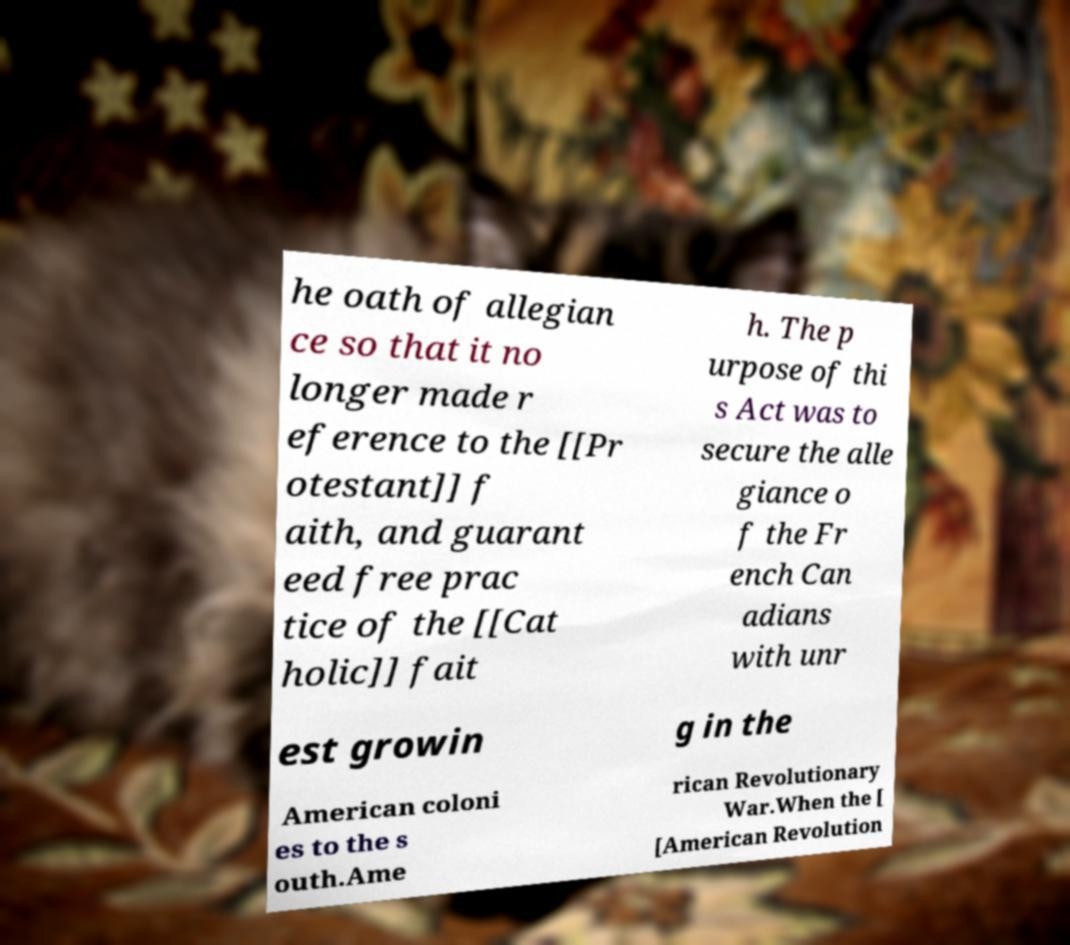I need the written content from this picture converted into text. Can you do that? he oath of allegian ce so that it no longer made r eference to the [[Pr otestant]] f aith, and guarant eed free prac tice of the [[Cat holic]] fait h. The p urpose of thi s Act was to secure the alle giance o f the Fr ench Can adians with unr est growin g in the American coloni es to the s outh.Ame rican Revolutionary War.When the [ [American Revolution 